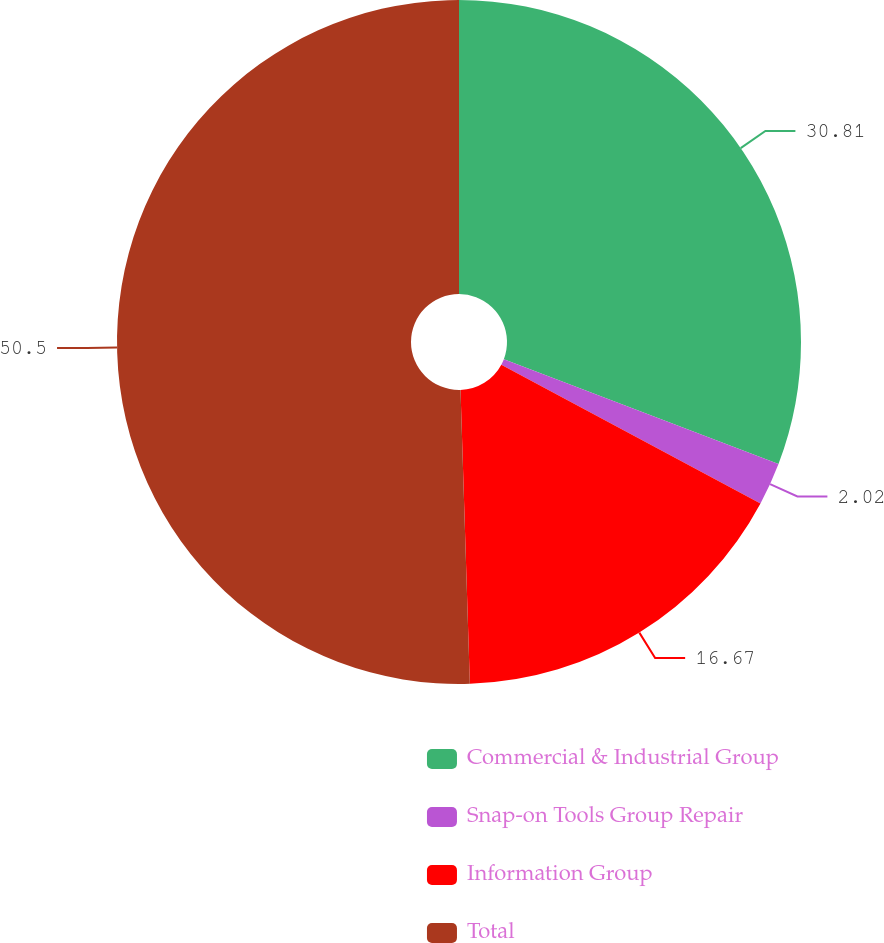Convert chart. <chart><loc_0><loc_0><loc_500><loc_500><pie_chart><fcel>Commercial & Industrial Group<fcel>Snap-on Tools Group Repair<fcel>Information Group<fcel>Total<nl><fcel>30.81%<fcel>2.02%<fcel>16.67%<fcel>50.51%<nl></chart> 